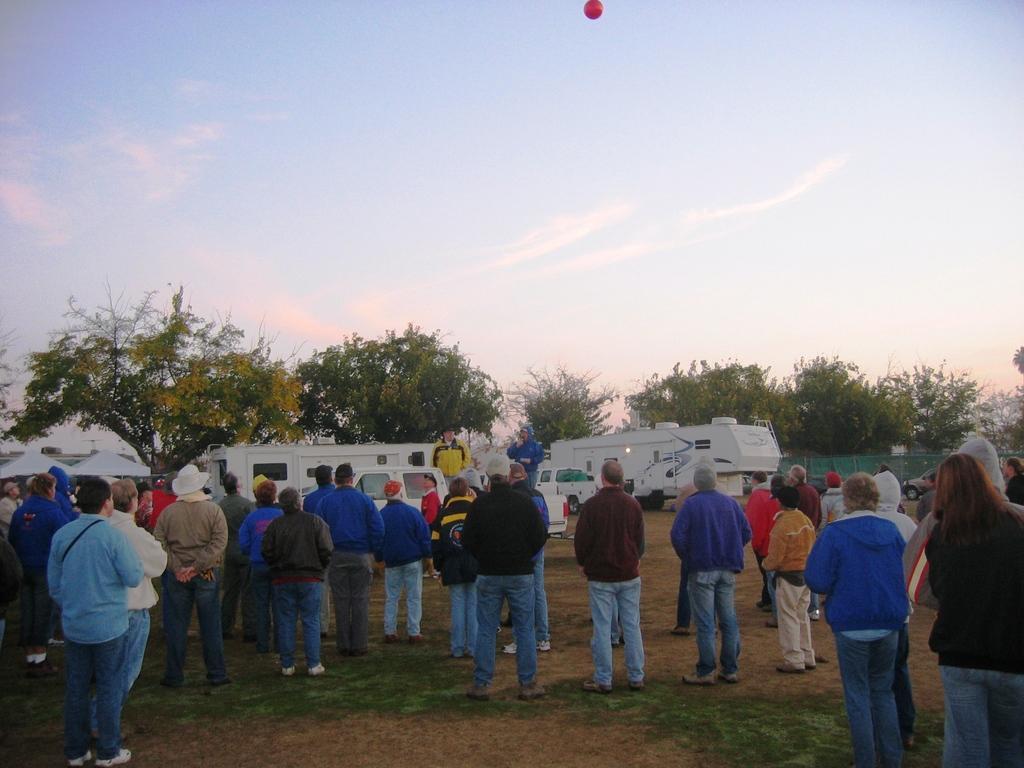How would you summarize this image in a sentence or two? In this image I can see group of people. They are wearing different color dress. I can see few vehicles which are in white color. I can see trees and green color fencing. The sky is in white and blue color. 